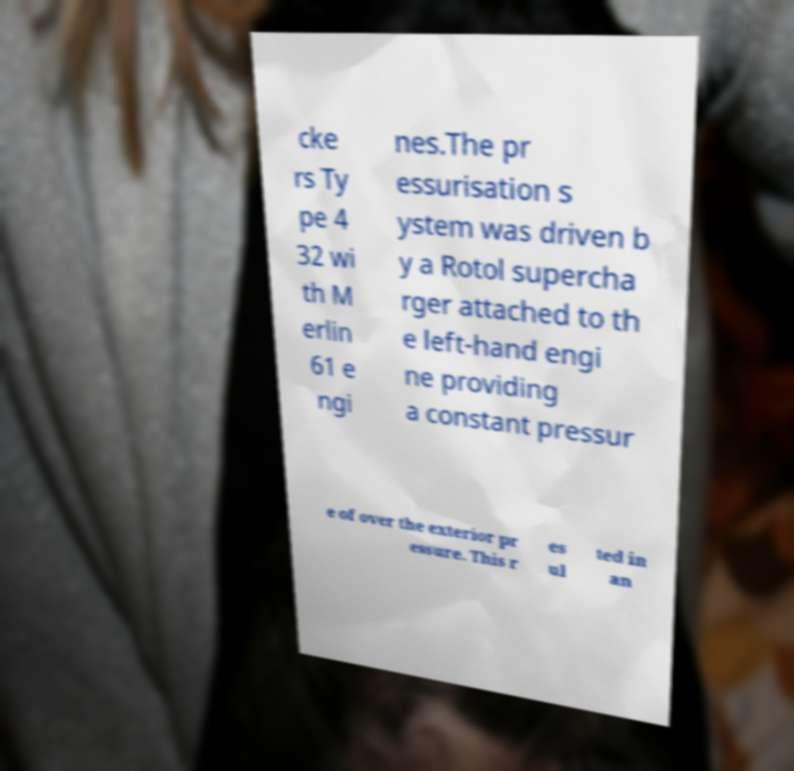Please read and relay the text visible in this image. What does it say? cke rs Ty pe 4 32 wi th M erlin 61 e ngi nes.The pr essurisation s ystem was driven b y a Rotol supercha rger attached to th e left-hand engi ne providing a constant pressur e of over the exterior pr essure. This r es ul ted in an 